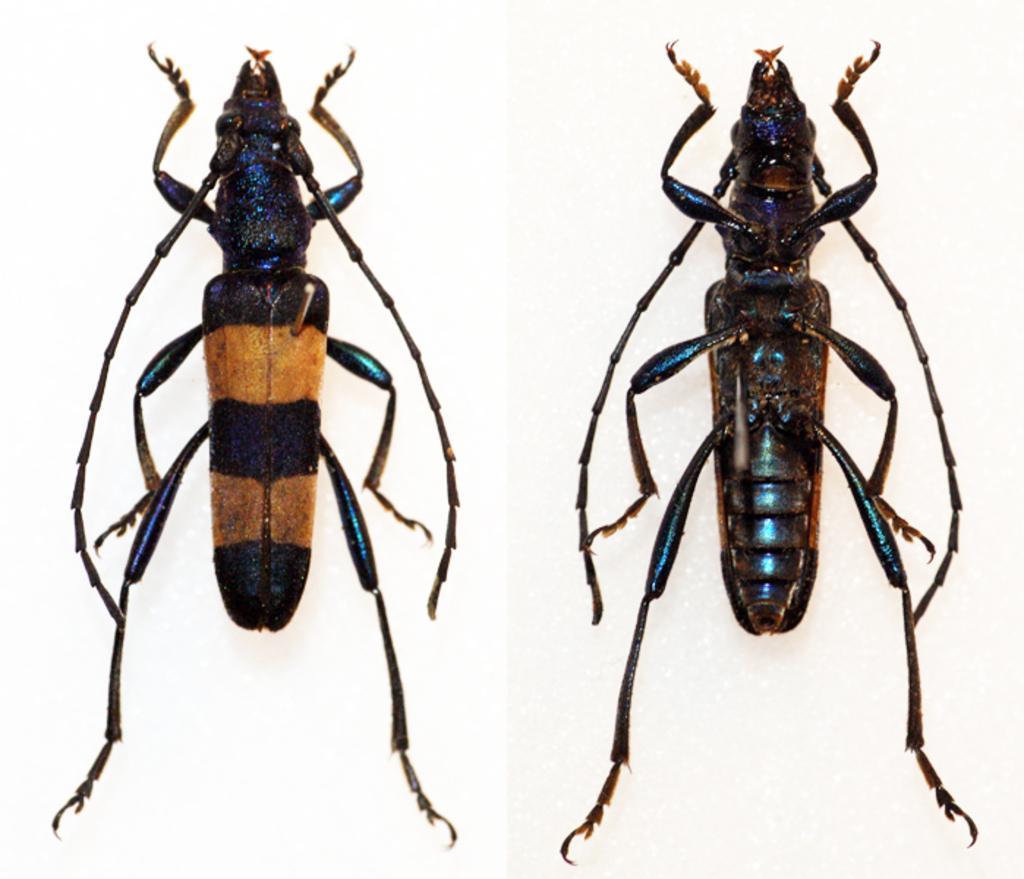In one or two sentences, can you explain what this image depicts? This is a collage picture. I can see two insects, and there is white background. 